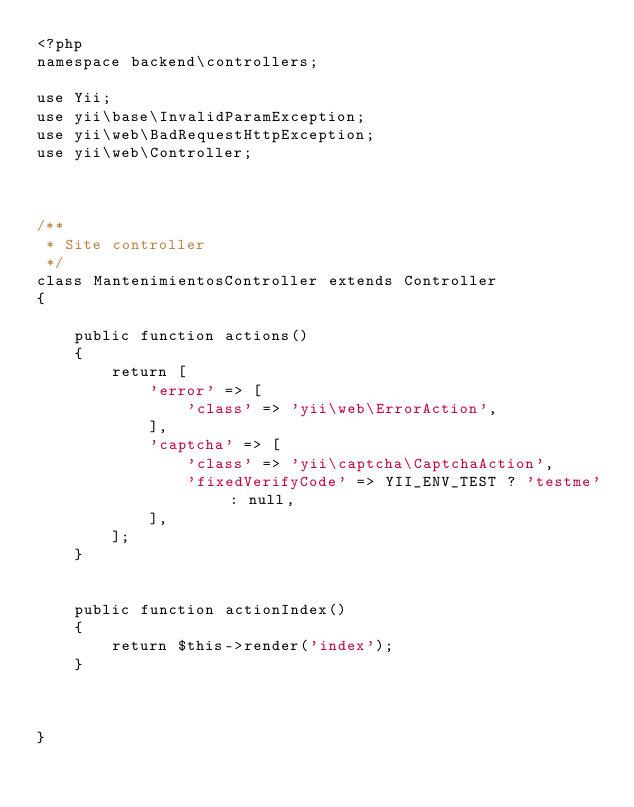Convert code to text. <code><loc_0><loc_0><loc_500><loc_500><_PHP_><?php
namespace backend\controllers;

use Yii;
use yii\base\InvalidParamException;
use yii\web\BadRequestHttpException;
use yii\web\Controller;



/**
 * Site controller
 */
class MantenimientosController extends Controller
{
  
    public function actions()
    {
        return [
            'error' => [
                'class' => 'yii\web\ErrorAction',
            ],
            'captcha' => [
                'class' => 'yii\captcha\CaptchaAction',
                'fixedVerifyCode' => YII_ENV_TEST ? 'testme' : null,
            ],
        ];
    }

    
    public function actionIndex()
    {
        return $this->render('index');
    }



}
</code> 